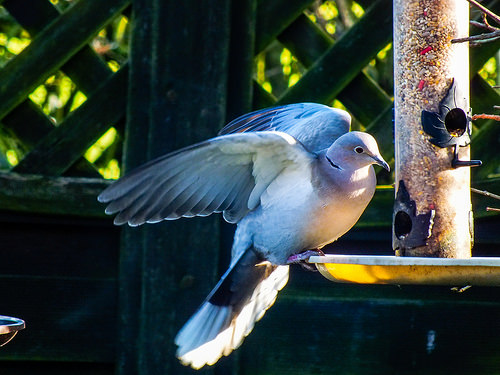<image>
Is there a dish on the bird? No. The dish is not positioned on the bird. They may be near each other, but the dish is not supported by or resting on top of the bird. Is there a bird behind the fence? No. The bird is not behind the fence. From this viewpoint, the bird appears to be positioned elsewhere in the scene. 